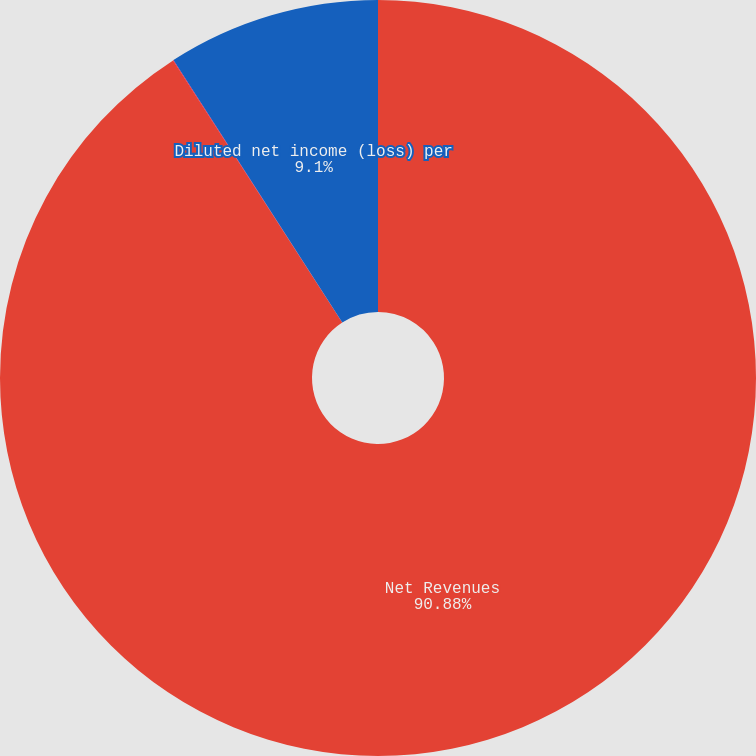Convert chart to OTSL. <chart><loc_0><loc_0><loc_500><loc_500><pie_chart><fcel>Net Revenues<fcel>Basic net income (loss) per<fcel>Diluted net income (loss) per<nl><fcel>90.88%<fcel>0.02%<fcel>9.1%<nl></chart> 